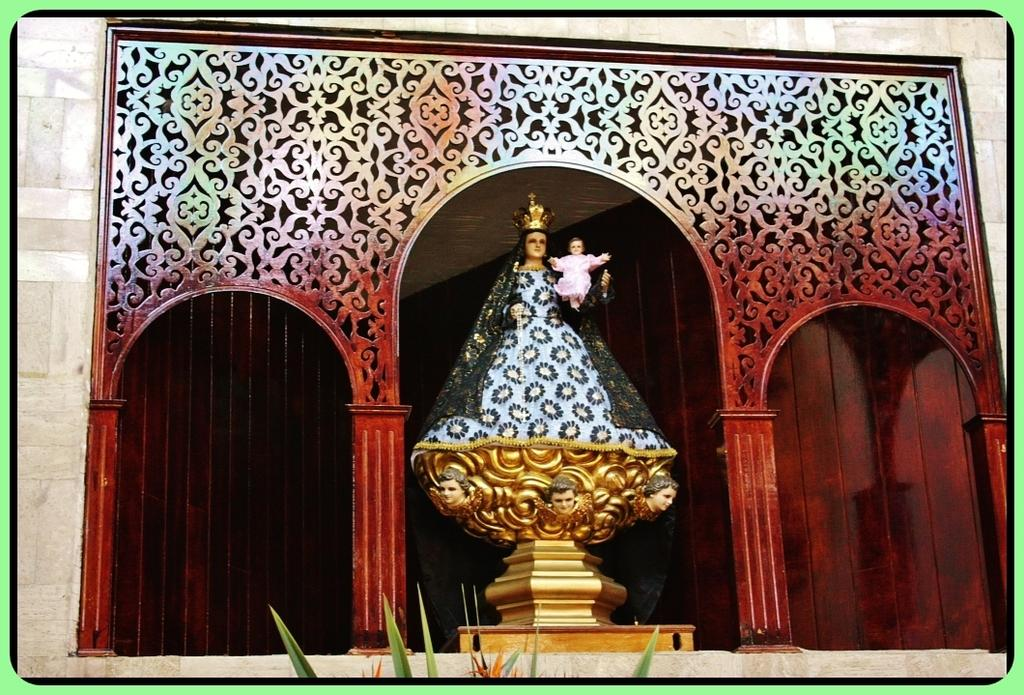What is the main subject in the foreground of the image? There is a sculpture in the foreground of the image. Can you describe the position of the sculpture in the foreground? The sculpture is in the middle of the foreground. What can be seen in the background of the image? There is a red wall in the background of the image. What type of vegetation is present at the bottom of the image? Plants are present at the bottom of the image. What type of clam is depicted in the verse written on the red wall in the image? There is no verse or clam present in the image; it features a sculpture in the foreground and a red wall in the background. 